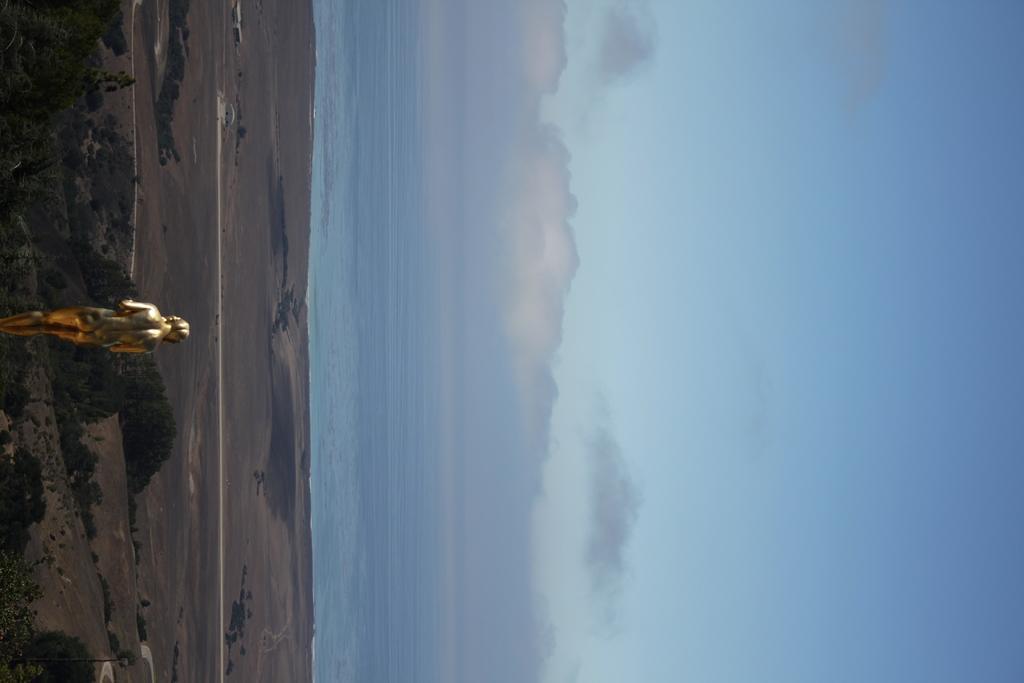Can you describe this image briefly? In this picture, we can see a statue, ground, trees water, and the sky with clouds. 